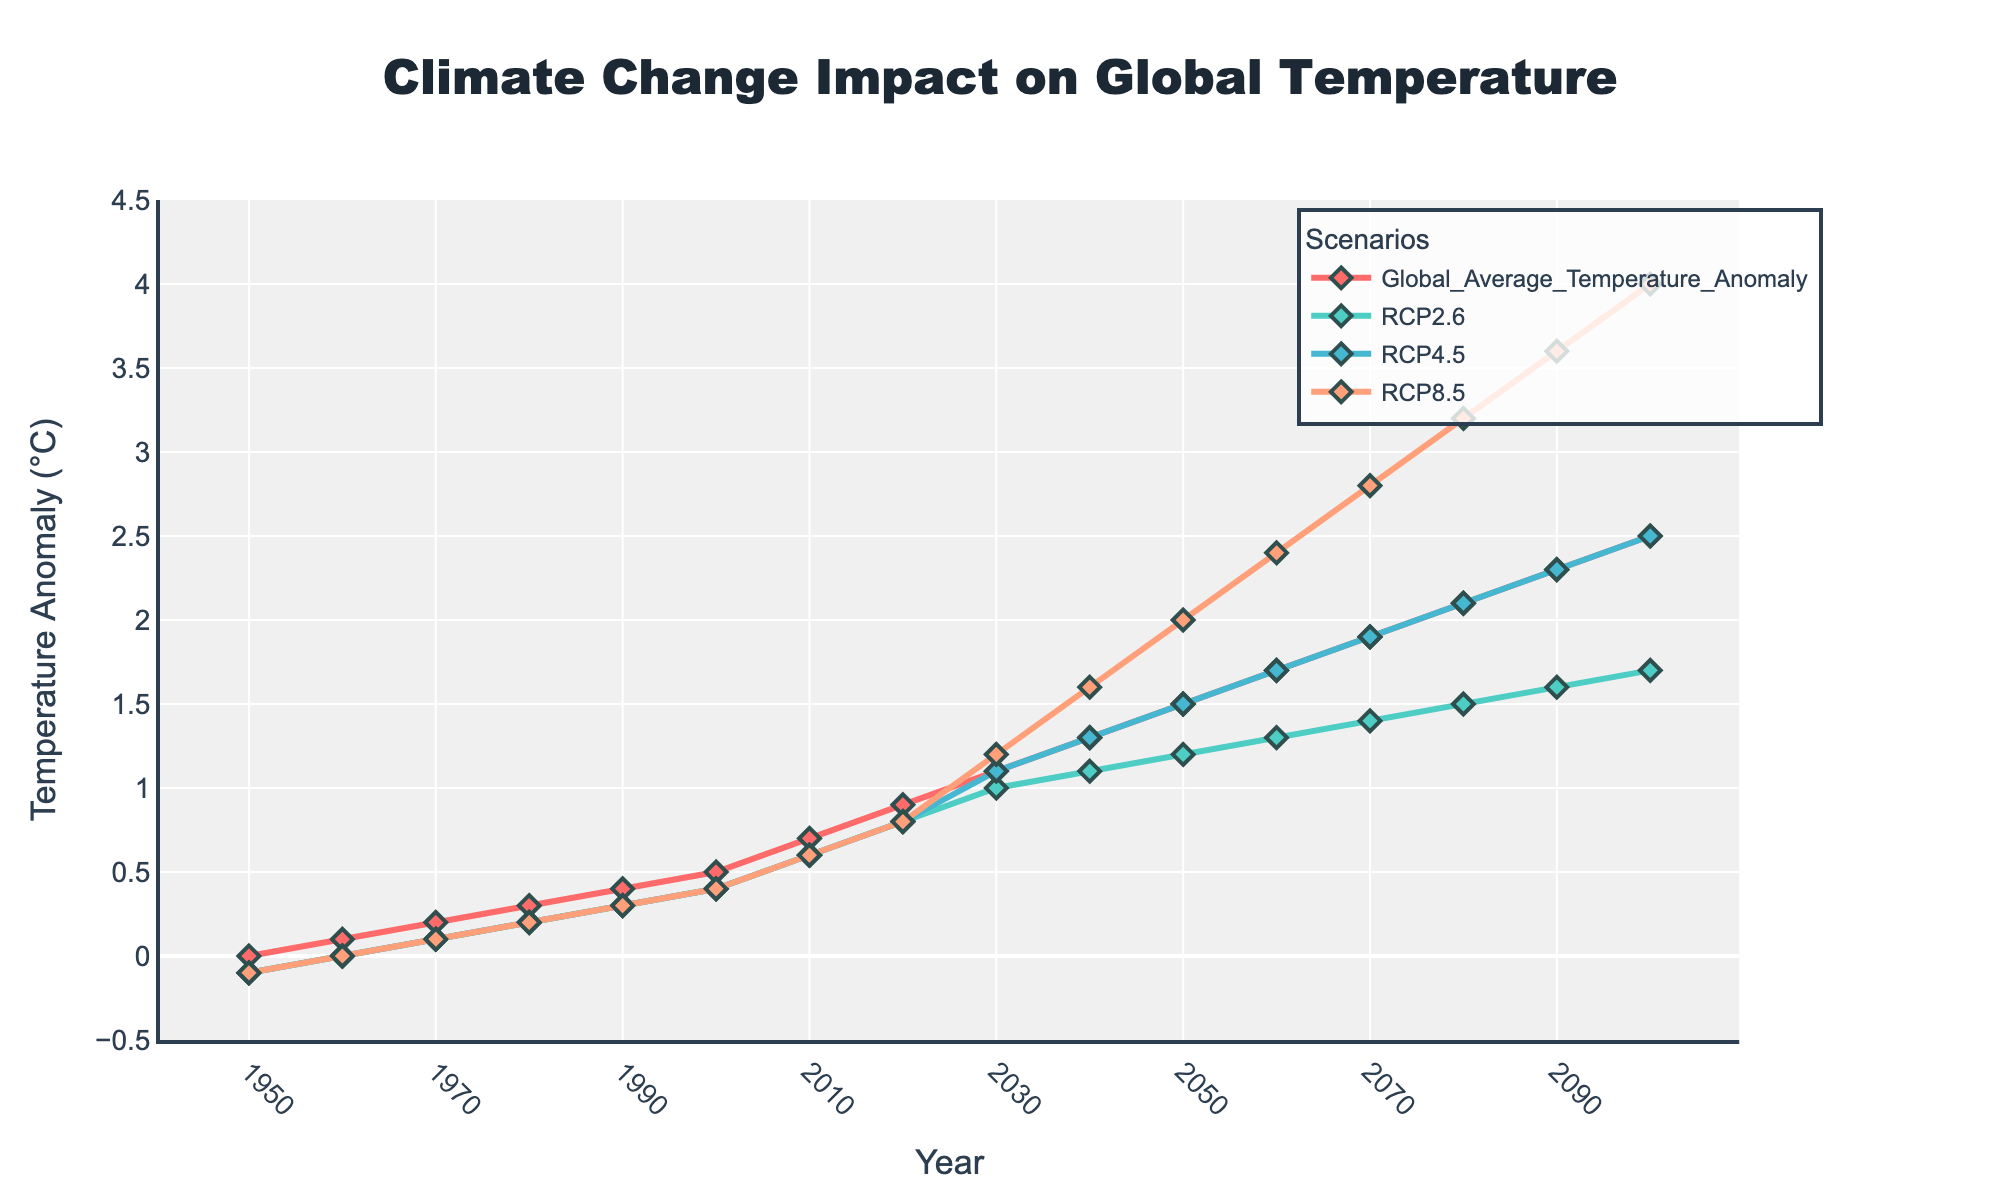What year does the Global Average Temperature Anomaly reach 0.9°C? The line represents the Global Average Temperature Anomaly over time. Observing the plotted points, we see that the anomaly of 0.9°C is first reached in the year 2020.
Answer: 2020 Comparing the RCP2.6 and RCP8.5 scenarios, which one shows a higher temperature anomaly in the year 2050? Looking at the plotted lines for RCP2.6 and RCP8.5 in the year 2050, we see RCP2.6 has around 1.2°C, while RCP8.5 is around 2.0°C. RCP8.5 shows a higher temperature anomaly.
Answer: RCP8.5 What's the increase in the Global Average Temperature Anomaly from 1950 to 2010? In 1950, the anomaly starts at 0.0°C and rises to 0.7°C by 2010. The increase can be calculated: 0.7 - 0.0 = 0.7°C.
Answer: 0.7°C Which scenario has the steepest increase from 2030 to 2100? Observing the slopes of the lines from 2030 to 2100, RCP8.5 shows the steepest increase, rising from around 1.2°C to 4.0°C.
Answer: RCP8.5 By how much does the RCP4.5 scenario increase from 2020 to 2100? The RCP4.5 scenario shows values at around 0.8°C in 2020 and around 2.5°C in 2100. The increase is calculated: 2.5 - 0.8 = 1.7°C.
Answer: 1.7°C In what year do all scenarios (RCP2.6, RCP4.5, and RCP8.5) diverge noticeably from the Global Average Temperature Anomaly? Noticing the plotted lines, we see a distinct divergence starting around the year 2030, where scenarios start showing different projections.
Answer: 2030 What is the average temperature anomaly for RCP2.6 between 2040 and 2060? RCP2.6 has values at approximately 1.1°C in 2040 and 1.3°C in 2060. The average is calculated: (1.1 + 1.3) / 2 = 1.2°C.
Answer: 1.2°C Which scenario has the lowest temperature anomaly in 2100? Looking at the end points of the graphs in the year 2100, RCP2.6 has the lowest temperature anomaly at around 1.7°C.
Answer: RCP2.6 What is the difference in temperature anomaly between RCP4.5 and RCP8.5 in 2080? In 2080, the RCP4.5 scenario is at approximately 2.1°C, while RCP8.5 is at approximately 3.2°C. The difference is calculated: 3.2 - 2.1 = 1.1°C.
Answer: 1.1°C 